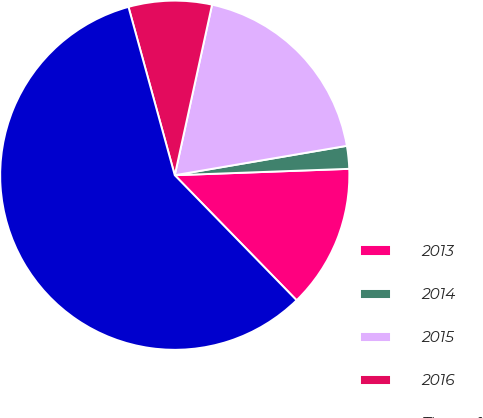Convert chart. <chart><loc_0><loc_0><loc_500><loc_500><pie_chart><fcel>2013<fcel>2014<fcel>2015<fcel>2016<fcel>Thereafter<nl><fcel>13.29%<fcel>2.11%<fcel>18.88%<fcel>7.7%<fcel>58.02%<nl></chart> 